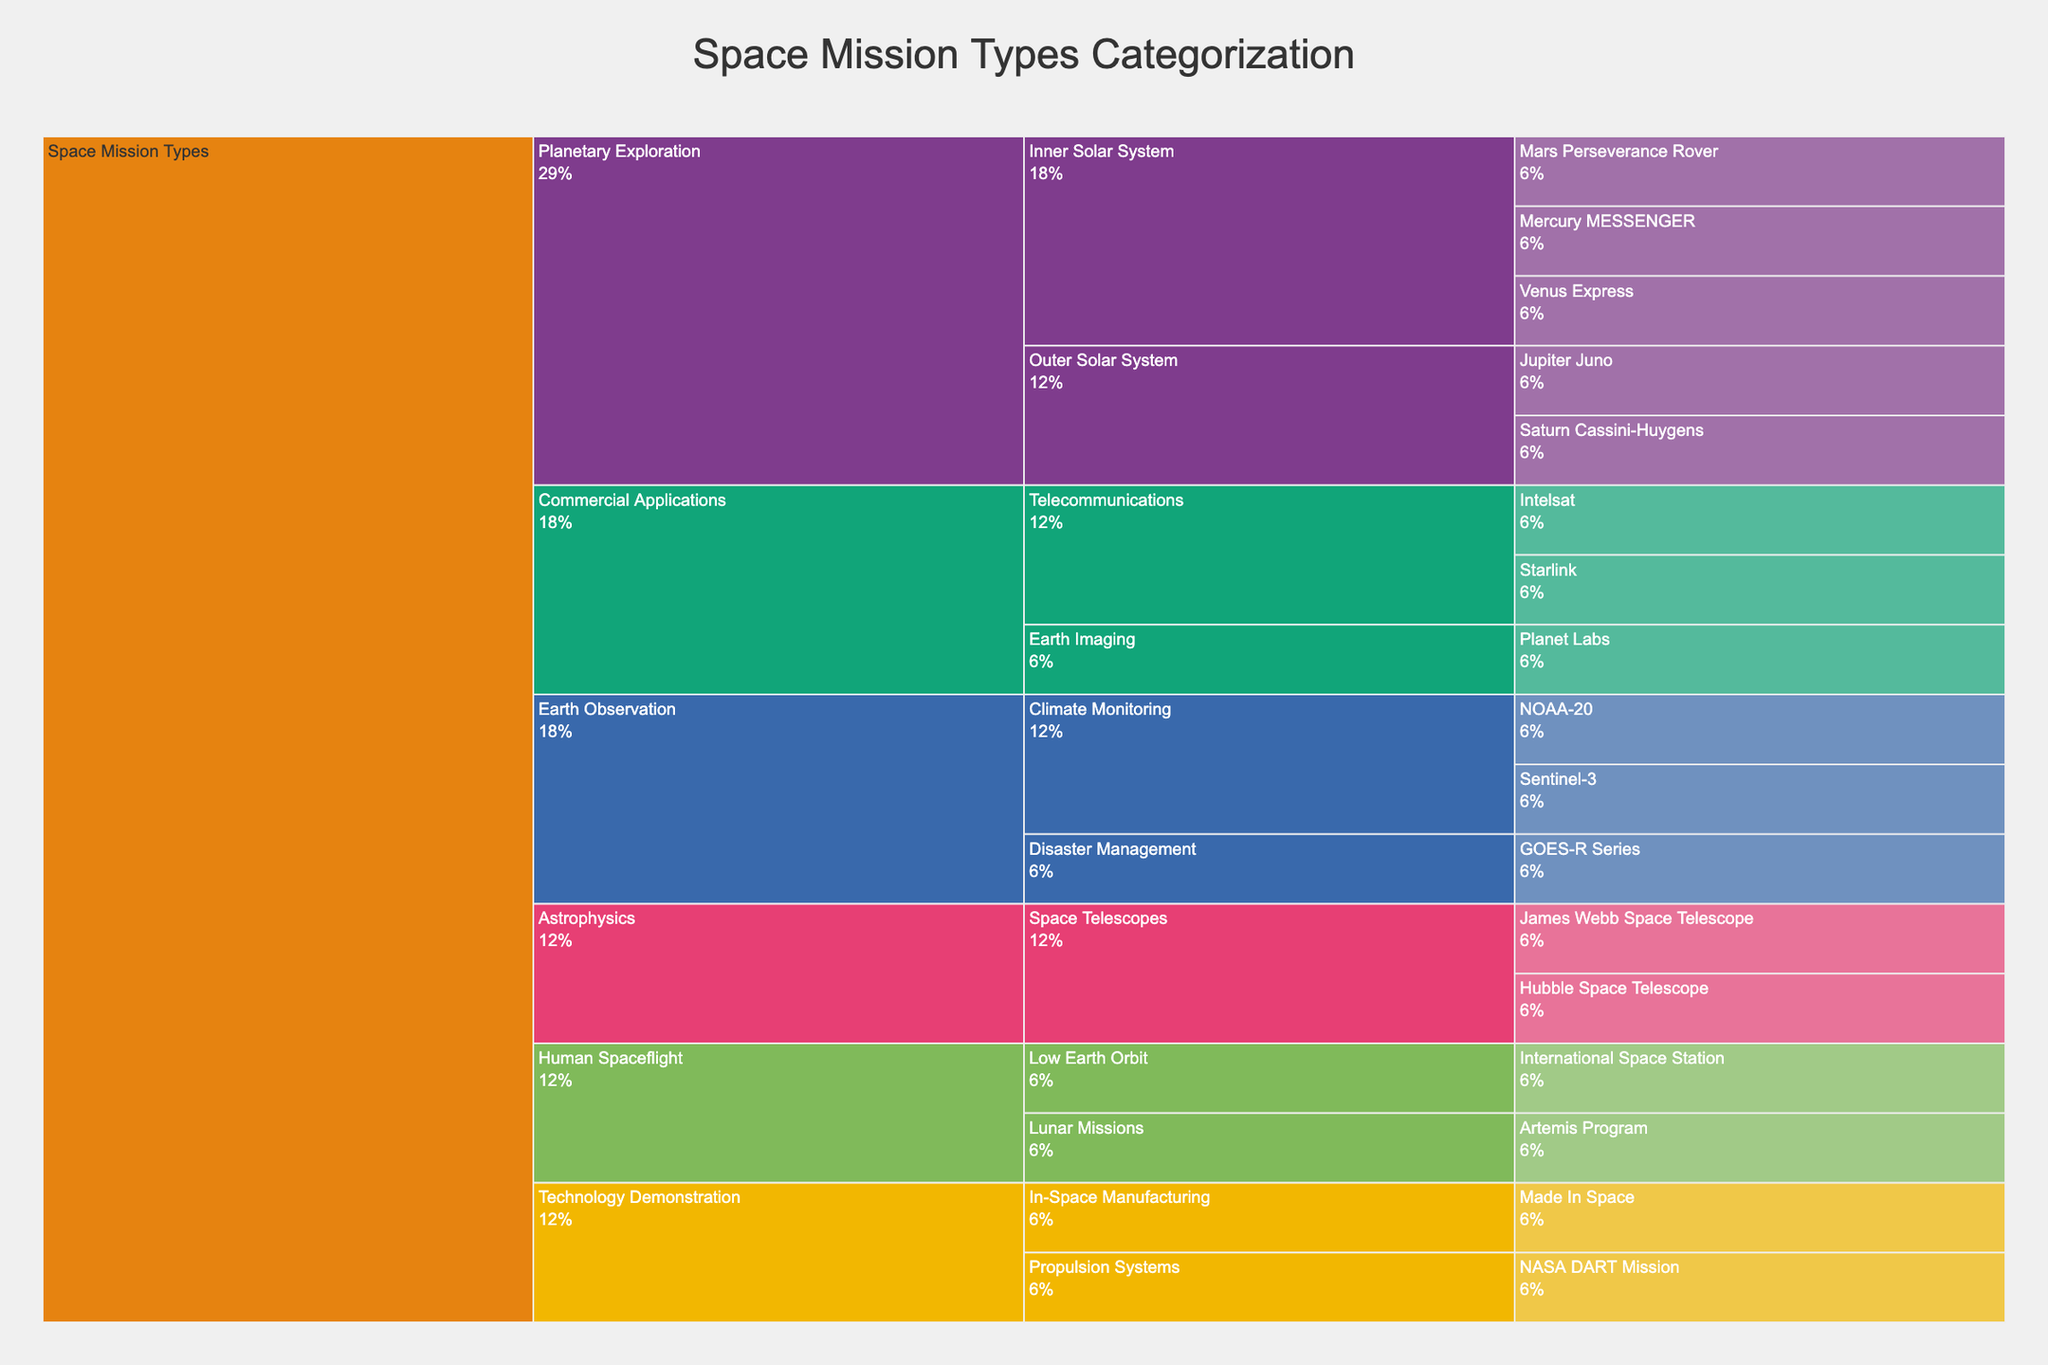What is the title of the chart? The title is usually displayed at the top of the chart. We see it as "Space Mission Types Categorization" in the chart.
Answer: Space Mission Types Categorization Which mission falls under the "Inner Solar System" subcategory of "Planetary Exploration"? Under "Planetary Exploration", the "Inner Solar System" subcategory includes "Mercury MESSENGER", "Venus Express", and "Mars Perseverance Rover" as specific missions.
Answer: Mercury MESSENGER, Venus Express, and Mars Perseverance Rover How many specific missions are categorized under "Commercial Applications"? Under "Commercial Applications", there are three specific missions: "Intelsat", "Starlink", and "Planet Labs".
Answer: 3 What percentage of missions are classified under "Astrophysics"? The Icicle Chart indicates the percentage of missions in each category. From the visual information, add up the percentages of subcategories under "Astrophysics". The detailed reasoning involves locating the label "Astrophysics" and noting the percentage associated with it.
Answer: Look at the chart Which category has more specific missions: "Telecommunications" or "Climate Monitoring"? "Telecommunications" and "Climate Monitoring" are subcategories under "Commercial Applications" and "Earth Observation", respectively. "Telecommunications" has "Intelsat" and "Starlink" while "Climate Monitoring" has "NOAA-20" and "Sentinel-3". Both have two specific missions each.
Answer: Equal What are the specific missions listed under "Technology Demonstration"? In the chart, find the "Technology Demonstration" category. The specific missions listed under "Technology Demonstration" are "NASA DART Mission" and "Made In Space".
Answer: NASA DART Mission and Made In Space Compare the number of missions in "Low Earth Orbit" to "Lunar Missions" subcategories of "Human Spaceflight". "Human Spaceflight" has two subcategories: "Low Earth Orbit" and "Lunar Missions". "Low Earth Orbit" has "International Space Station", and "Lunar Missions" has "Artemis Program". Each subcategory has one mission.
Answer: Equal Identify a specific mission in the "Disaster Management" subcategory of "Earth Observation". Under "Earth Observation", the "Disaster Management" subcategory includes the specific mission "GOES-R Series".
Answer: GOES-R Series 